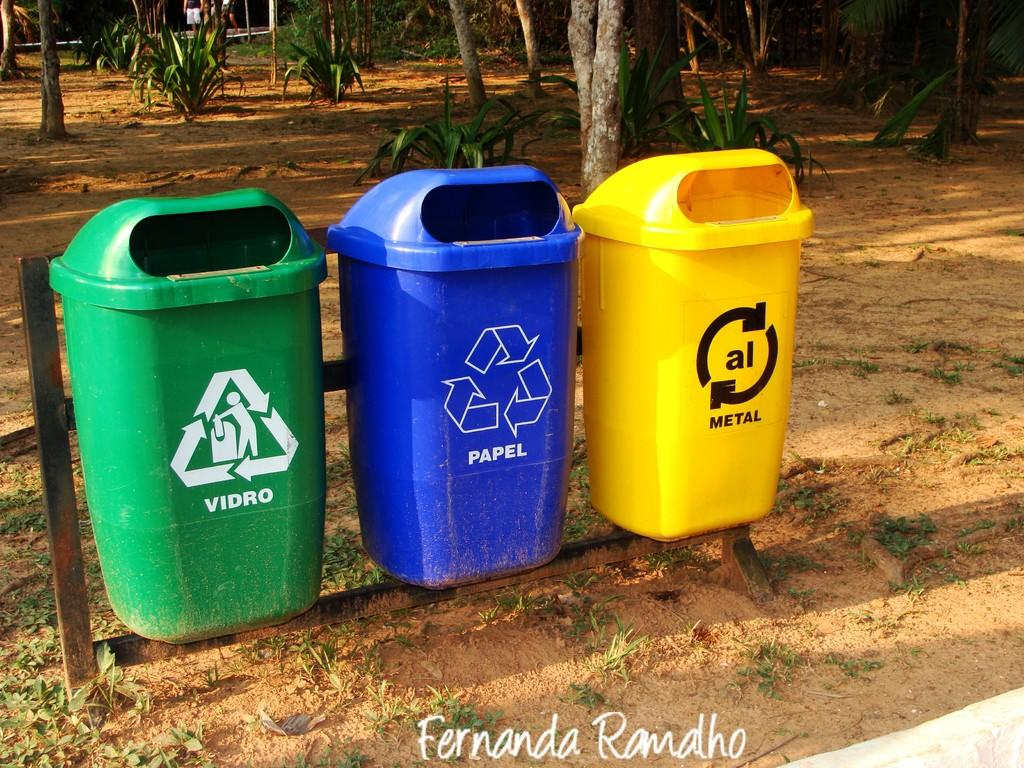<image>
Describe the image concisely. A yellow recycling basket is labeled for metal. 